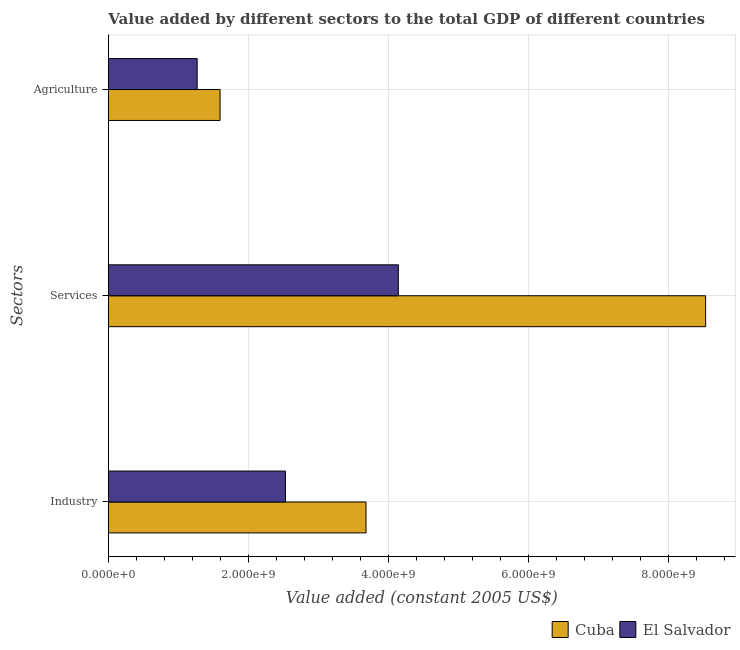How many different coloured bars are there?
Provide a short and direct response. 2. Are the number of bars per tick equal to the number of legend labels?
Offer a terse response. Yes. How many bars are there on the 1st tick from the top?
Offer a terse response. 2. What is the label of the 3rd group of bars from the top?
Your response must be concise. Industry. What is the value added by services in Cuba?
Your answer should be very brief. 8.53e+09. Across all countries, what is the maximum value added by agricultural sector?
Offer a terse response. 1.59e+09. Across all countries, what is the minimum value added by industrial sector?
Give a very brief answer. 2.53e+09. In which country was the value added by services maximum?
Your answer should be very brief. Cuba. In which country was the value added by industrial sector minimum?
Provide a short and direct response. El Salvador. What is the total value added by agricultural sector in the graph?
Give a very brief answer. 2.86e+09. What is the difference between the value added by industrial sector in El Salvador and that in Cuba?
Keep it short and to the point. -1.15e+09. What is the difference between the value added by industrial sector in Cuba and the value added by agricultural sector in El Salvador?
Provide a succinct answer. 2.41e+09. What is the average value added by agricultural sector per country?
Your answer should be very brief. 1.43e+09. What is the difference between the value added by industrial sector and value added by agricultural sector in Cuba?
Offer a very short reply. 2.08e+09. What is the ratio of the value added by industrial sector in El Salvador to that in Cuba?
Your answer should be very brief. 0.69. Is the value added by agricultural sector in El Salvador less than that in Cuba?
Offer a terse response. Yes. What is the difference between the highest and the second highest value added by industrial sector?
Make the answer very short. 1.15e+09. What is the difference between the highest and the lowest value added by services?
Keep it short and to the point. 4.39e+09. In how many countries, is the value added by services greater than the average value added by services taken over all countries?
Provide a succinct answer. 1. Is the sum of the value added by services in Cuba and El Salvador greater than the maximum value added by industrial sector across all countries?
Your answer should be very brief. Yes. What does the 2nd bar from the top in Agriculture represents?
Provide a succinct answer. Cuba. What does the 1st bar from the bottom in Services represents?
Offer a terse response. Cuba. Are all the bars in the graph horizontal?
Your answer should be compact. Yes. How many countries are there in the graph?
Your answer should be very brief. 2. What is the difference between two consecutive major ticks on the X-axis?
Offer a terse response. 2.00e+09. Are the values on the major ticks of X-axis written in scientific E-notation?
Keep it short and to the point. Yes. Where does the legend appear in the graph?
Keep it short and to the point. Bottom right. How many legend labels are there?
Keep it short and to the point. 2. What is the title of the graph?
Your answer should be compact. Value added by different sectors to the total GDP of different countries. Does "Liberia" appear as one of the legend labels in the graph?
Provide a succinct answer. No. What is the label or title of the X-axis?
Your response must be concise. Value added (constant 2005 US$). What is the label or title of the Y-axis?
Offer a very short reply. Sectors. What is the Value added (constant 2005 US$) in Cuba in Industry?
Give a very brief answer. 3.68e+09. What is the Value added (constant 2005 US$) of El Salvador in Industry?
Your answer should be very brief. 2.53e+09. What is the Value added (constant 2005 US$) in Cuba in Services?
Make the answer very short. 8.53e+09. What is the Value added (constant 2005 US$) in El Salvador in Services?
Offer a very short reply. 4.14e+09. What is the Value added (constant 2005 US$) in Cuba in Agriculture?
Give a very brief answer. 1.59e+09. What is the Value added (constant 2005 US$) in El Salvador in Agriculture?
Offer a very short reply. 1.27e+09. Across all Sectors, what is the maximum Value added (constant 2005 US$) of Cuba?
Make the answer very short. 8.53e+09. Across all Sectors, what is the maximum Value added (constant 2005 US$) in El Salvador?
Provide a short and direct response. 4.14e+09. Across all Sectors, what is the minimum Value added (constant 2005 US$) of Cuba?
Provide a short and direct response. 1.59e+09. Across all Sectors, what is the minimum Value added (constant 2005 US$) of El Salvador?
Your answer should be very brief. 1.27e+09. What is the total Value added (constant 2005 US$) of Cuba in the graph?
Ensure brevity in your answer.  1.38e+1. What is the total Value added (constant 2005 US$) in El Salvador in the graph?
Your response must be concise. 7.94e+09. What is the difference between the Value added (constant 2005 US$) of Cuba in Industry and that in Services?
Your answer should be compact. -4.85e+09. What is the difference between the Value added (constant 2005 US$) in El Salvador in Industry and that in Services?
Give a very brief answer. -1.61e+09. What is the difference between the Value added (constant 2005 US$) in Cuba in Industry and that in Agriculture?
Your answer should be very brief. 2.08e+09. What is the difference between the Value added (constant 2005 US$) in El Salvador in Industry and that in Agriculture?
Your response must be concise. 1.26e+09. What is the difference between the Value added (constant 2005 US$) in Cuba in Services and that in Agriculture?
Provide a short and direct response. 6.94e+09. What is the difference between the Value added (constant 2005 US$) of El Salvador in Services and that in Agriculture?
Keep it short and to the point. 2.87e+09. What is the difference between the Value added (constant 2005 US$) of Cuba in Industry and the Value added (constant 2005 US$) of El Salvador in Services?
Offer a very short reply. -4.62e+08. What is the difference between the Value added (constant 2005 US$) in Cuba in Industry and the Value added (constant 2005 US$) in El Salvador in Agriculture?
Make the answer very short. 2.41e+09. What is the difference between the Value added (constant 2005 US$) in Cuba in Services and the Value added (constant 2005 US$) in El Salvador in Agriculture?
Your answer should be compact. 7.26e+09. What is the average Value added (constant 2005 US$) of Cuba per Sectors?
Give a very brief answer. 4.60e+09. What is the average Value added (constant 2005 US$) in El Salvador per Sectors?
Provide a succinct answer. 2.65e+09. What is the difference between the Value added (constant 2005 US$) in Cuba and Value added (constant 2005 US$) in El Salvador in Industry?
Provide a succinct answer. 1.15e+09. What is the difference between the Value added (constant 2005 US$) in Cuba and Value added (constant 2005 US$) in El Salvador in Services?
Provide a short and direct response. 4.39e+09. What is the difference between the Value added (constant 2005 US$) of Cuba and Value added (constant 2005 US$) of El Salvador in Agriculture?
Offer a very short reply. 3.27e+08. What is the ratio of the Value added (constant 2005 US$) of Cuba in Industry to that in Services?
Ensure brevity in your answer.  0.43. What is the ratio of the Value added (constant 2005 US$) of El Salvador in Industry to that in Services?
Ensure brevity in your answer.  0.61. What is the ratio of the Value added (constant 2005 US$) in Cuba in Industry to that in Agriculture?
Your answer should be very brief. 2.31. What is the ratio of the Value added (constant 2005 US$) of El Salvador in Industry to that in Agriculture?
Make the answer very short. 1.99. What is the ratio of the Value added (constant 2005 US$) of Cuba in Services to that in Agriculture?
Offer a very short reply. 5.35. What is the ratio of the Value added (constant 2005 US$) of El Salvador in Services to that in Agriculture?
Provide a succinct answer. 3.27. What is the difference between the highest and the second highest Value added (constant 2005 US$) of Cuba?
Ensure brevity in your answer.  4.85e+09. What is the difference between the highest and the second highest Value added (constant 2005 US$) of El Salvador?
Keep it short and to the point. 1.61e+09. What is the difference between the highest and the lowest Value added (constant 2005 US$) in Cuba?
Keep it short and to the point. 6.94e+09. What is the difference between the highest and the lowest Value added (constant 2005 US$) in El Salvador?
Offer a very short reply. 2.87e+09. 